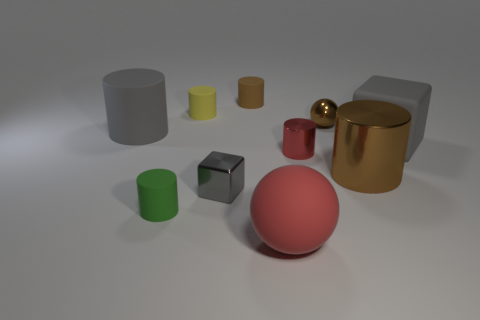Subtract 2 cylinders. How many cylinders are left? 4 Subtract all large matte cylinders. How many cylinders are left? 5 Subtract all green cylinders. How many cylinders are left? 5 Subtract all brown cylinders. Subtract all gray spheres. How many cylinders are left? 4 Subtract all cylinders. How many objects are left? 4 Add 3 big matte cylinders. How many big matte cylinders exist? 4 Subtract 1 yellow cylinders. How many objects are left? 9 Subtract all tiny purple metal cylinders. Subtract all large brown metal cylinders. How many objects are left? 9 Add 6 large metallic cylinders. How many large metallic cylinders are left? 7 